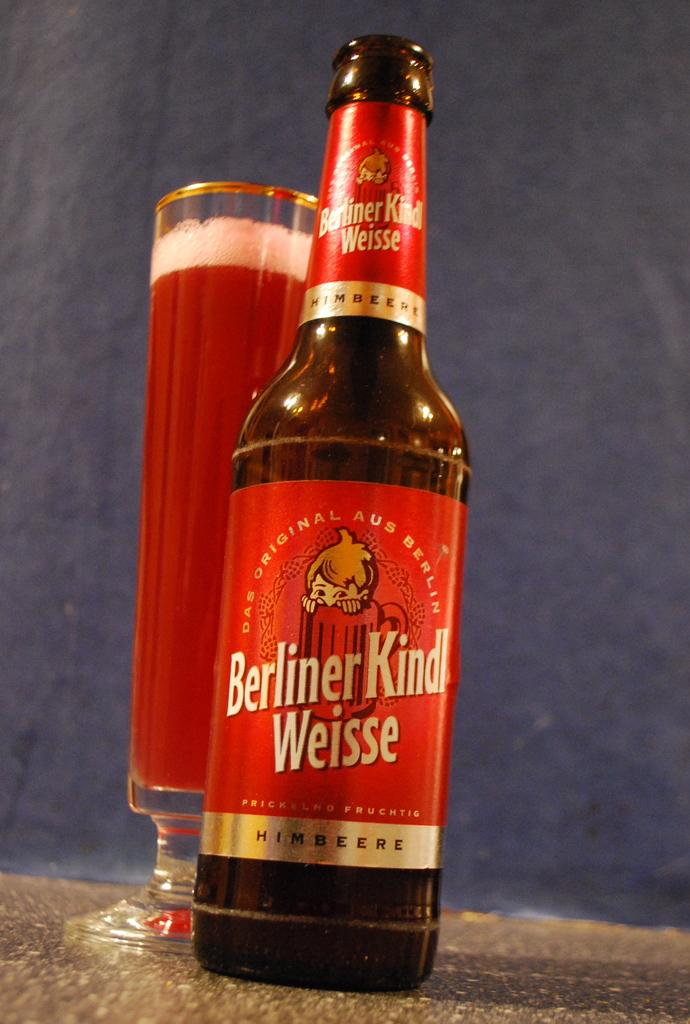<image>
Share a concise interpretation of the image provided. Glass sitting behind bottle of Berliner Kinl Weisse 